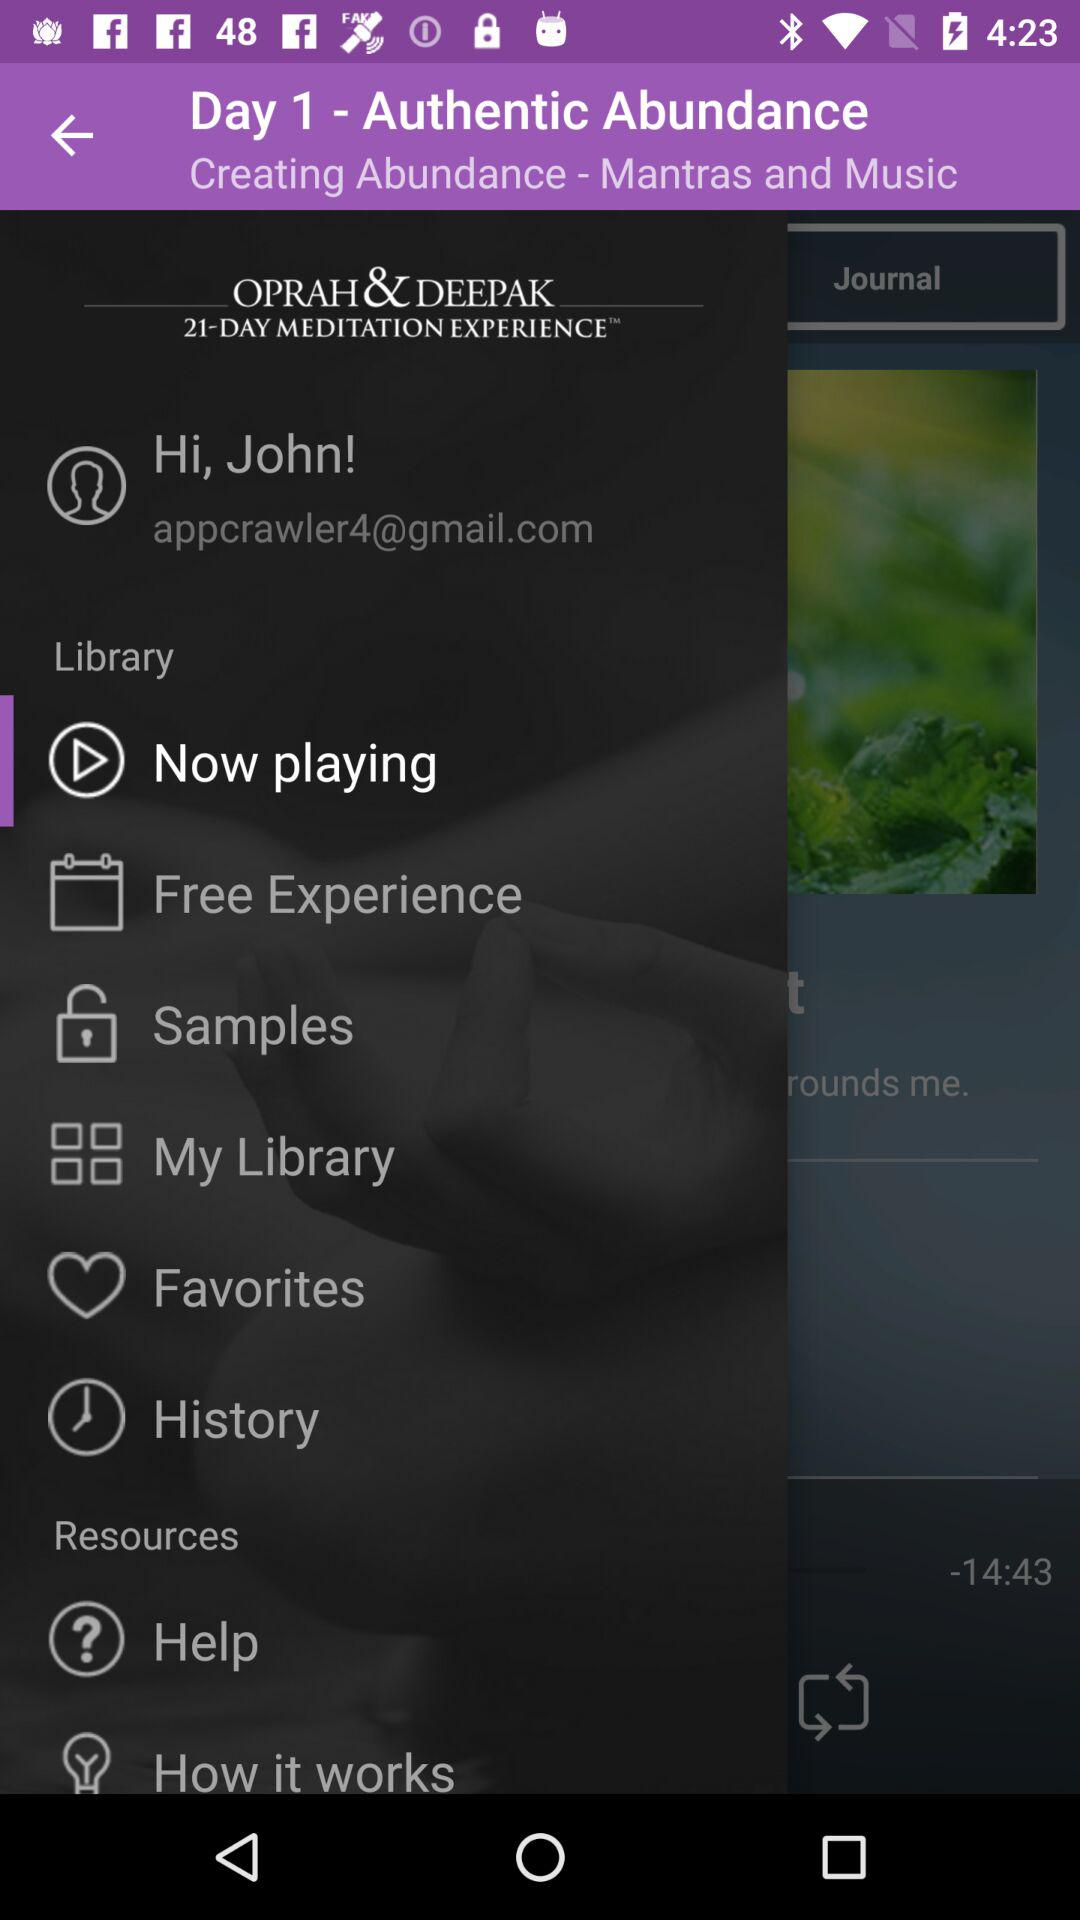What is the name of the user? The name of the user is John. 